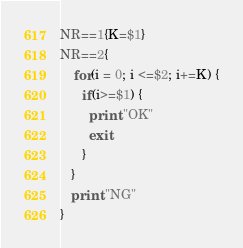Convert code to text. <code><loc_0><loc_0><loc_500><loc_500><_Awk_>NR==1{K=$1}
NR==2{
	for(i = 0; i <=$2; i+=K) {
      if(i>=$1) {
      	print "OK"
      	exit
      }
   }
   print "NG"
}</code> 